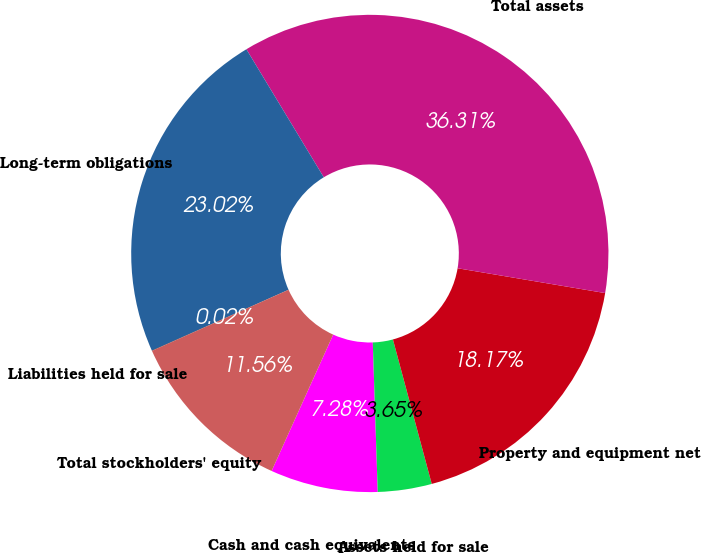Convert chart to OTSL. <chart><loc_0><loc_0><loc_500><loc_500><pie_chart><fcel>Cash and cash equivalents<fcel>Assets held for sale<fcel>Property and equipment net<fcel>Total assets<fcel>Long-term obligations<fcel>Liabilities held for sale<fcel>Total stockholders' equity<nl><fcel>7.28%<fcel>3.65%<fcel>18.17%<fcel>36.31%<fcel>23.02%<fcel>0.02%<fcel>11.56%<nl></chart> 